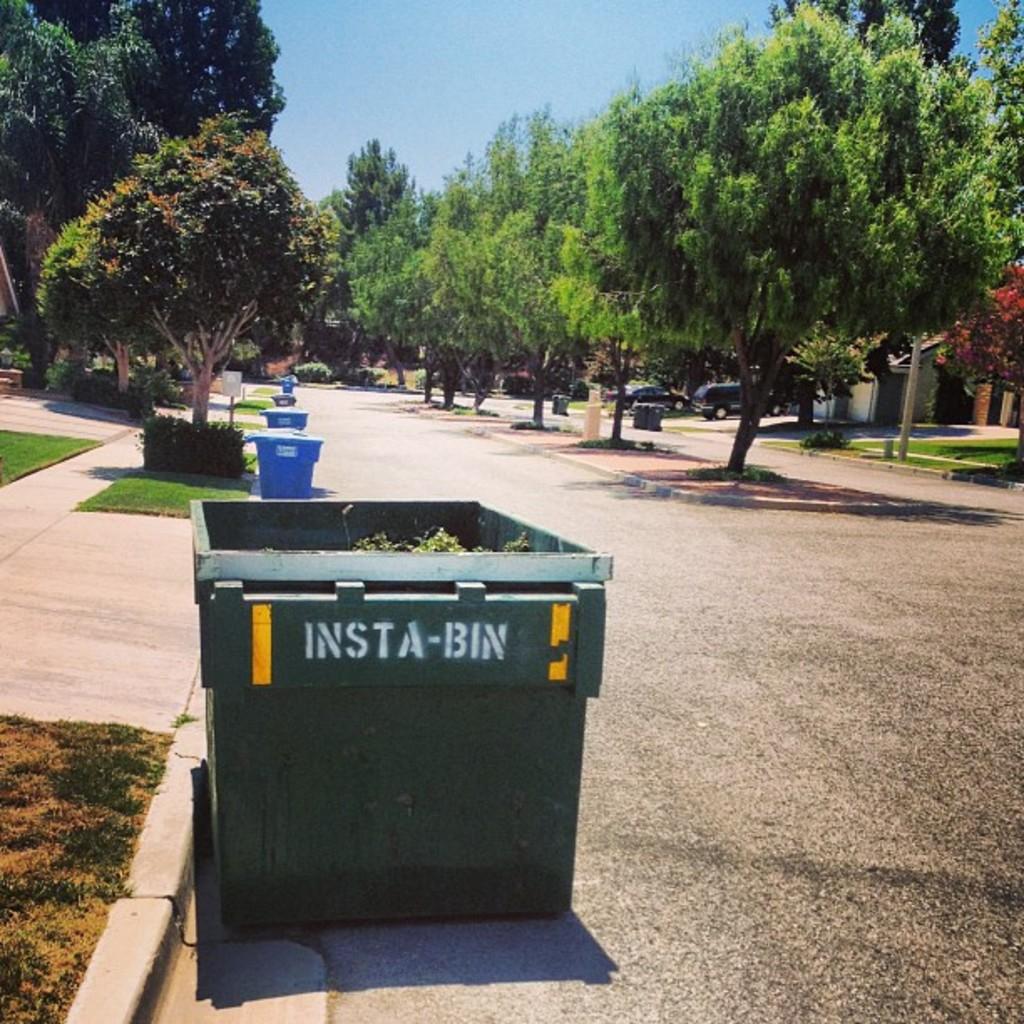What are these style of bins called?
Provide a short and direct response. Insta-bin. What is the brand of this dumpster?
Offer a very short reply. Insta-bin. 